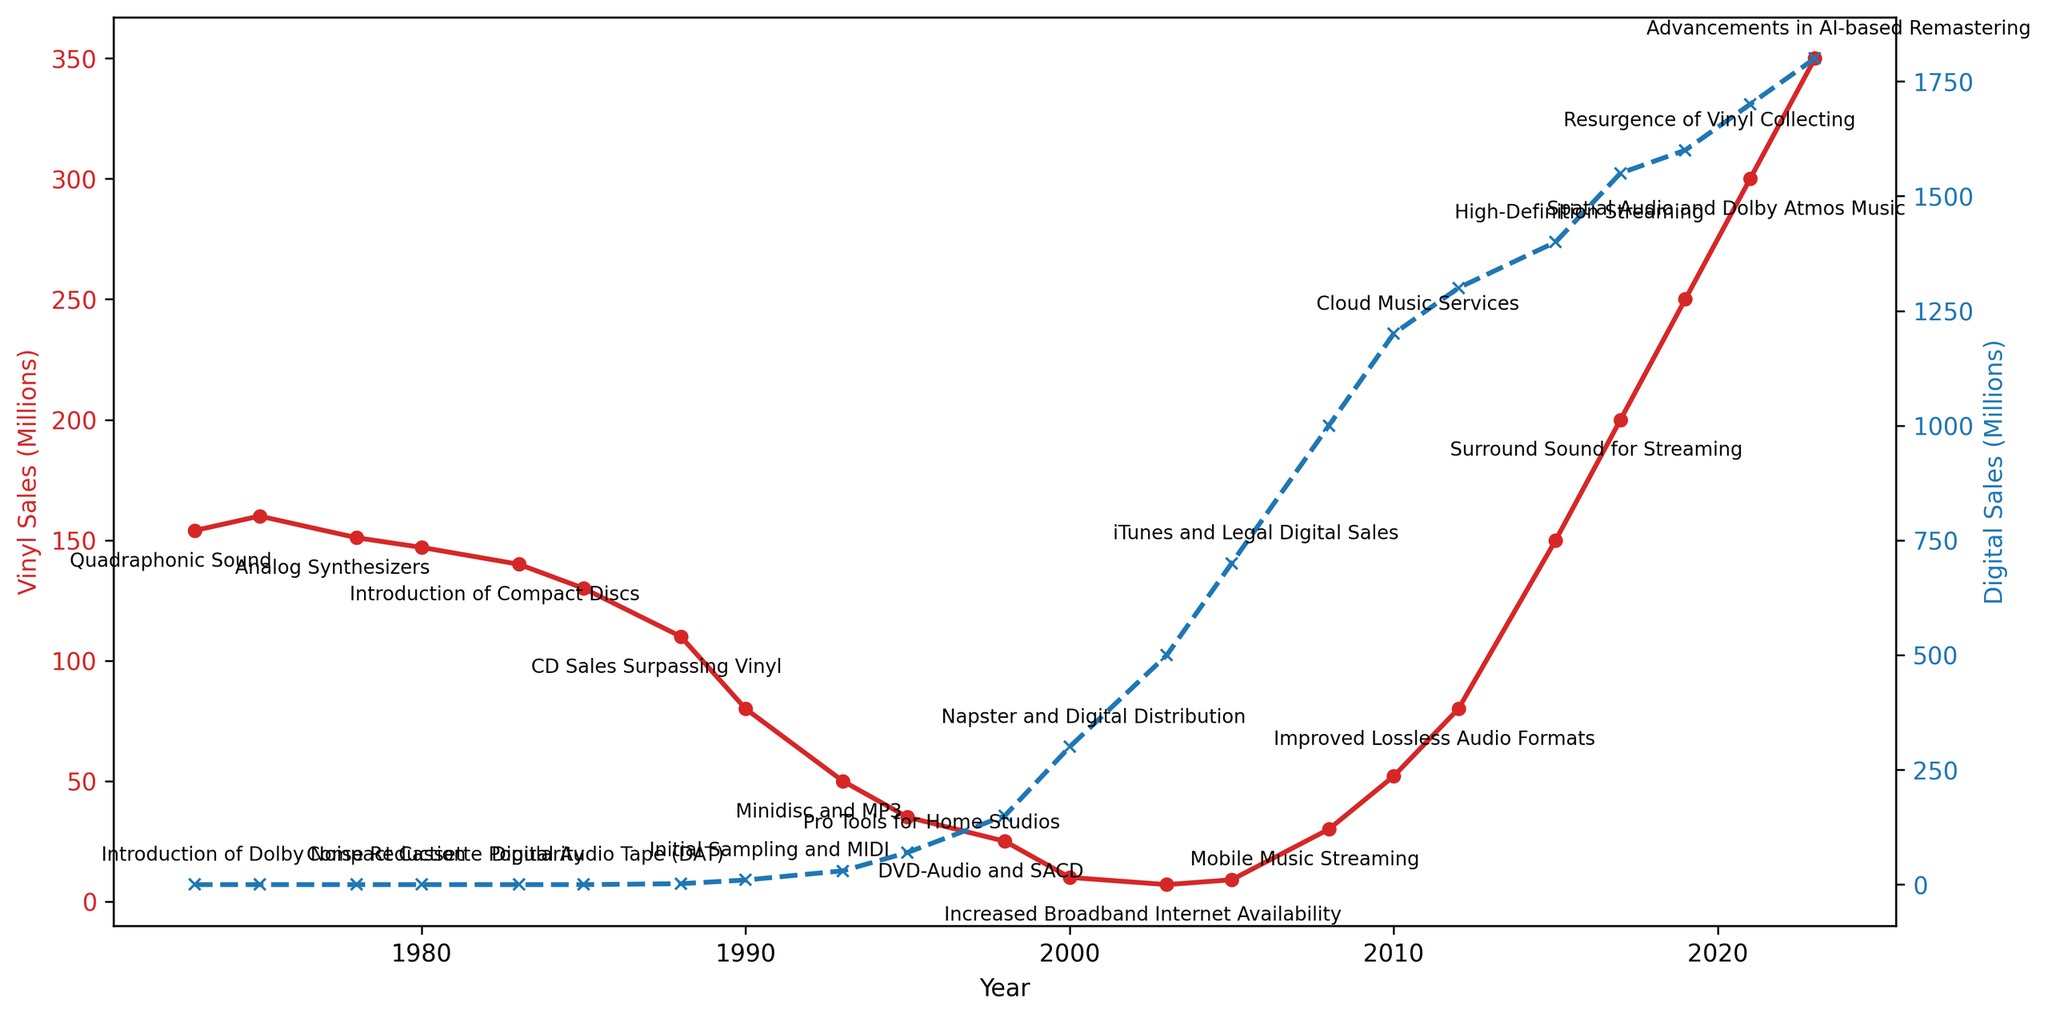What year did digital sales first surpass vinyl sales? In the figure, look for the intersection point where the digital sales line (in blue) overtakes the vinyl sales line (in red). This occurs in 1998.
Answer: 1998 Which year showed the highest vinyl sales according to the chart? The red line representing vinyl sales reaches its highest point at the beginning of the chart. The highest value is 154 million in 1973.
Answer: 1973 Compare the growth trend of digital sales between 2008 and 2010 with vinyl sales between the same period. During 2008 to 2010, the blue line representing digital sales grows steadily from 1000 million to 1200 million, an increase of 200 million. The red line for vinyl sales also increases, but from 30 million to 52 million, resulting in an increase of 22 million. This shows that digital sales grew more in absolute terms over these years.
Answer: Digital sales grew more What are the two technological advances annotated around the year 1985, and how do they correlate with vinyl and digital sales at that time? Around 1985, the annotations are 'Digital Audio Tape (DAT)' and 'Introduction of Compact Discs'. At this point, vinyl sales are declining, evidenced by the downward slope of the red line, and digital sales are very low, starting to rise slowly.
Answer: Digital Audio Tape (DAT) and Introduction of Compact Discs; vinyl sales declining, digital sales starting to rise Identify the first major recording technology advance after 2000 that coincides with a rapid increase in digital sales. The blue line takes a steeper upward trend post-2000 with the annotation 'Napster and Digital Distribution' appearing around 2000. This marks the beginning of rapid digital sales growth.
Answer: Napster and Digital Distribution Which year marked the resurgence of vinyl collecting according to the figure, and how is it visually indicated? The annotation 'Resurgence of Vinyl Collecting' appears around the year 2019 on the red line. This marks a point where there is noticeable growth in vinyl sales.
Answer: 2019 Calculate the difference in vinyl sales between the highest and the lowest points shown in the chart. The highest point for vinyl sales is 154 million in 1973. The lowest point is 7 million in 2003. Subtracting the lowest from the highest gives 154 - 7 = 147 million.
Answer: 147 million What is the technological annotation in 2021, and how has it impacted the sales trend? The annotation for 2021 is 'Spatial Audio and Dolby Atmos Music'. This coincides with a continued increase in both vinyl and digital sales, as seen by the upward slope of both the red and blue lines around this year.
Answer: Spatial Audio and Dolby Atmos Music; increase in both sales Compare the digital sales in 2005 to the vinyl sales in the same year. According to the chart, in 2005, digital sales are at 700 million (blue line) while vinyl sales are at 9 million (red line). This shows digital sales are significantly higher than vinyl sales in that year.
Answer: Digital sales are significantly higher How does the figure visually differentiate vinyl sales from digital sales? The figure uses two different colored lines to represent the two sales types: red for vinyl sales and blue for digital sales. The left y-axis quantifies vinyl sales while the right y-axis quantifies digital sales. Additionally, different markers 'o' for vinyl and 'x' for digital help differentiate the lines.
Answer: Red line for vinyl, blue line for digital 